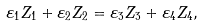Convert formula to latex. <formula><loc_0><loc_0><loc_500><loc_500>\varepsilon _ { 1 } Z _ { 1 } + \varepsilon _ { 2 } Z _ { 2 } = \varepsilon _ { 3 } Z _ { 3 } + \varepsilon _ { 4 } Z _ { 4 } ,</formula> 